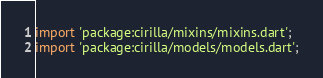<code> <loc_0><loc_0><loc_500><loc_500><_Dart_>import 'package:cirilla/mixins/mixins.dart';
import 'package:cirilla/models/models.dart';</code> 